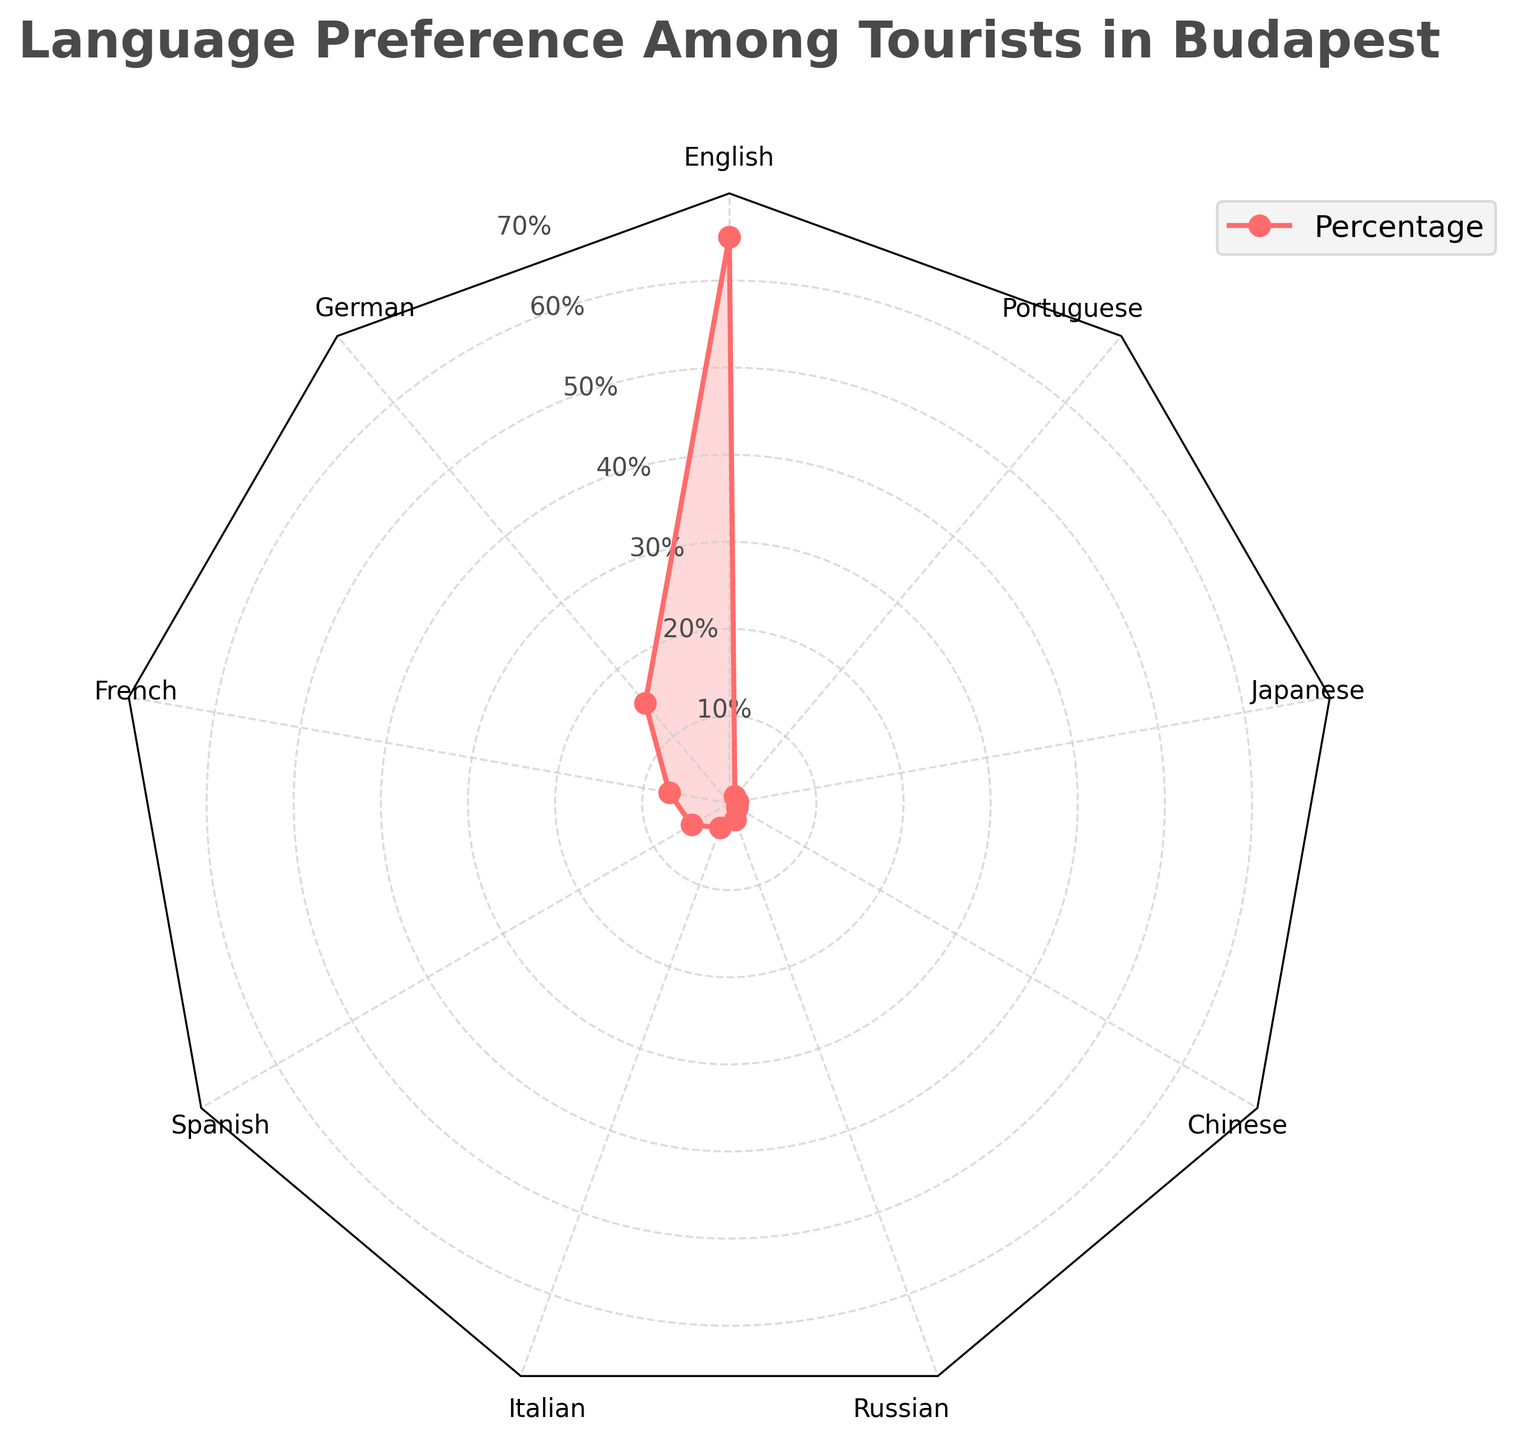What's the title of the radar chart? The title of the radar chart is typically displayed at the top and summarizes the content of the chart. In this case, it reads "Language Preference Among Tourists in Budapest."
Answer: Language Preference Among Tourists in Budapest What is the highest percentage of language preference among tourists visiting Budapest? The highest percentage on the radar chart is represented by the language with the largest value extending outward. From the chart, English has the longest length, corresponding to 65%.
Answer: 65% Which language has the second-highest percentage after English? After identifying English with 65%, the next highest value on the chart is German with 15%.
Answer: German How many languages have less than 5% preference among tourists? Count the segments of the radar chart where the percentage is less than 5%. The languages are Italian (3%), Russian (2%), Chinese (1%), Japanese (1%), and Portuguese (1%). That makes five languages.
Answer: 5 Is the preference for German greater than the combined preference for French and Spanish? Compare the values for German (15%) with the sum of French (7%) and Spanish (5%). The combined preference for French and Spanish is 7% + 5% = 12%, which is less than 15%.
Answer: Yes Which languages have the same percentage of preference among tourists? Identify and compare the percentages. Chinese, Japanese, and Portuguese all have a 1% preference.
Answer: Chinese, Japanese, Portuguese What is the total percentage covered by the top three preferred languages? Add the percentages of English (65%), German (15%), and French (7%). So, 65% + 15% + 7% = 87%.
Answer: 87% What percentage do Italian and Russian languages together account for? Calculate the combined percentage by adding Italian (3%) and Russian (2%). Thus, 3% + 2% = 5%.
Answer: 5% Which language segment is directly opposite to German on the radar chart? Identify German's position on the chart and look at the language directly across, which is Spanish.
Answer: Spanish 